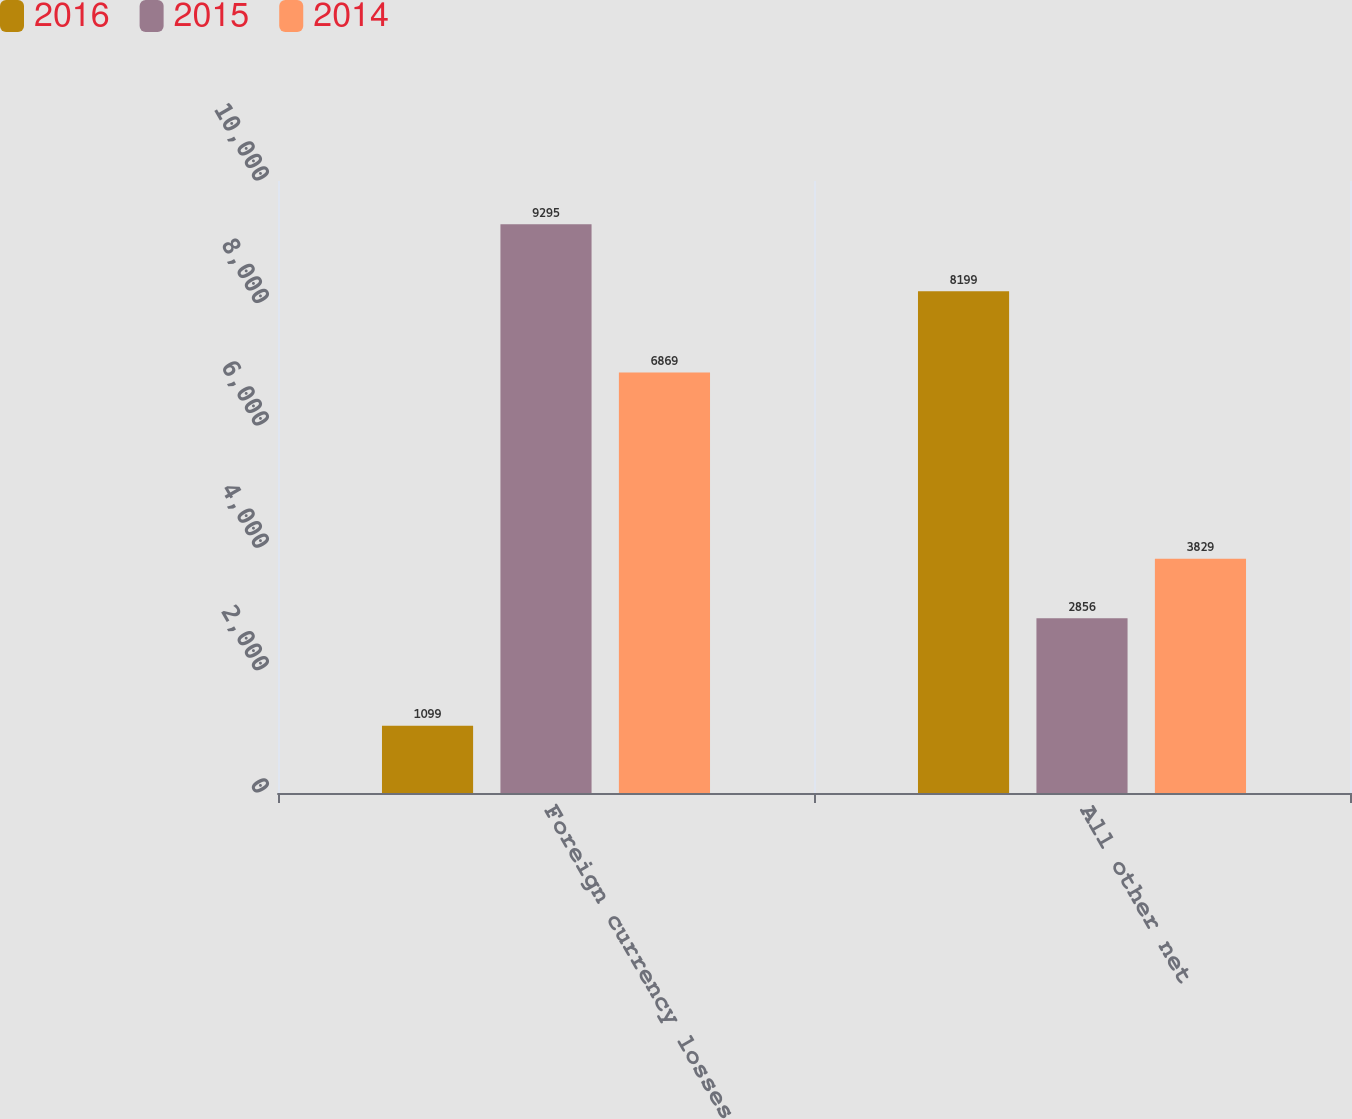Convert chart to OTSL. <chart><loc_0><loc_0><loc_500><loc_500><stacked_bar_chart><ecel><fcel>Foreign currency losses<fcel>All other net<nl><fcel>2016<fcel>1099<fcel>8199<nl><fcel>2015<fcel>9295<fcel>2856<nl><fcel>2014<fcel>6869<fcel>3829<nl></chart> 